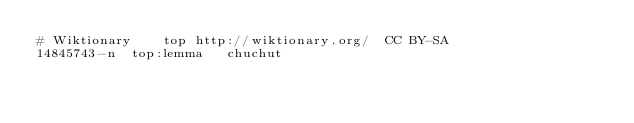<code> <loc_0><loc_0><loc_500><loc_500><_SQL_># Wiktionary	top	http://wiktionary.org/	CC BY-SA
14845743-n	top:lemma	chuchut
</code> 